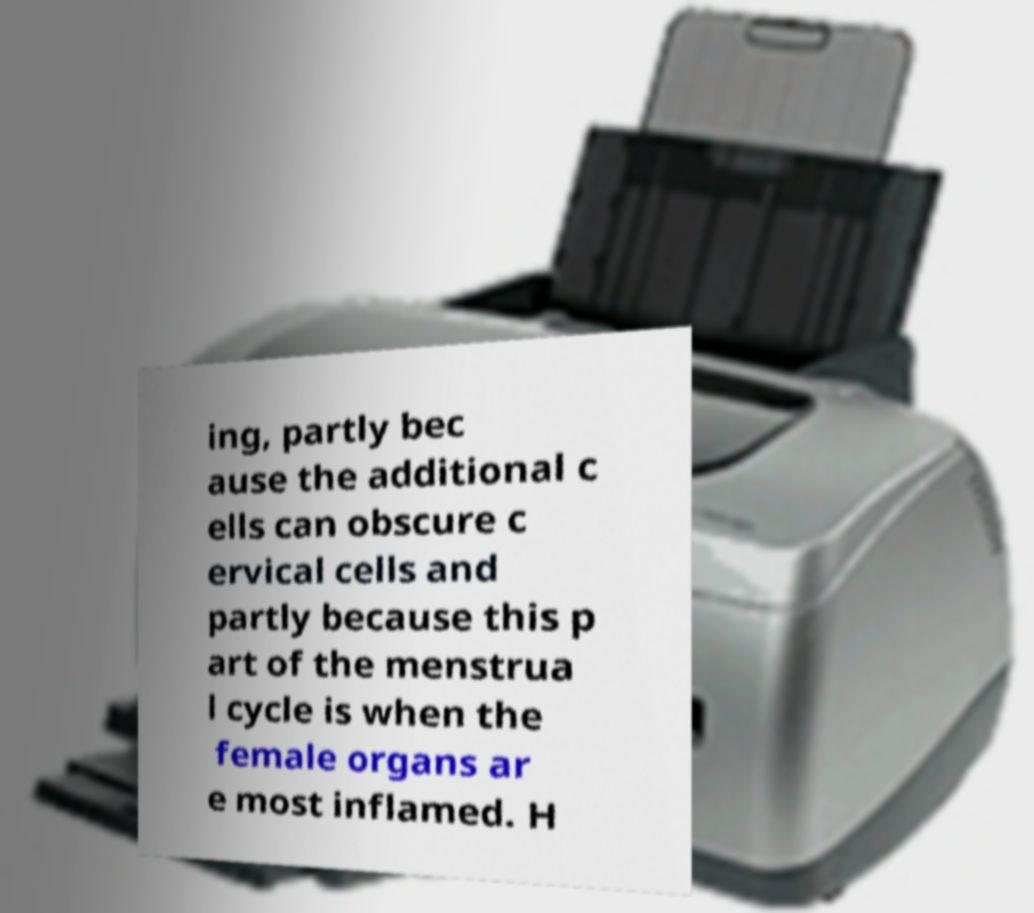I need the written content from this picture converted into text. Can you do that? ing, partly bec ause the additional c ells can obscure c ervical cells and partly because this p art of the menstrua l cycle is when the female organs ar e most inflamed. H 